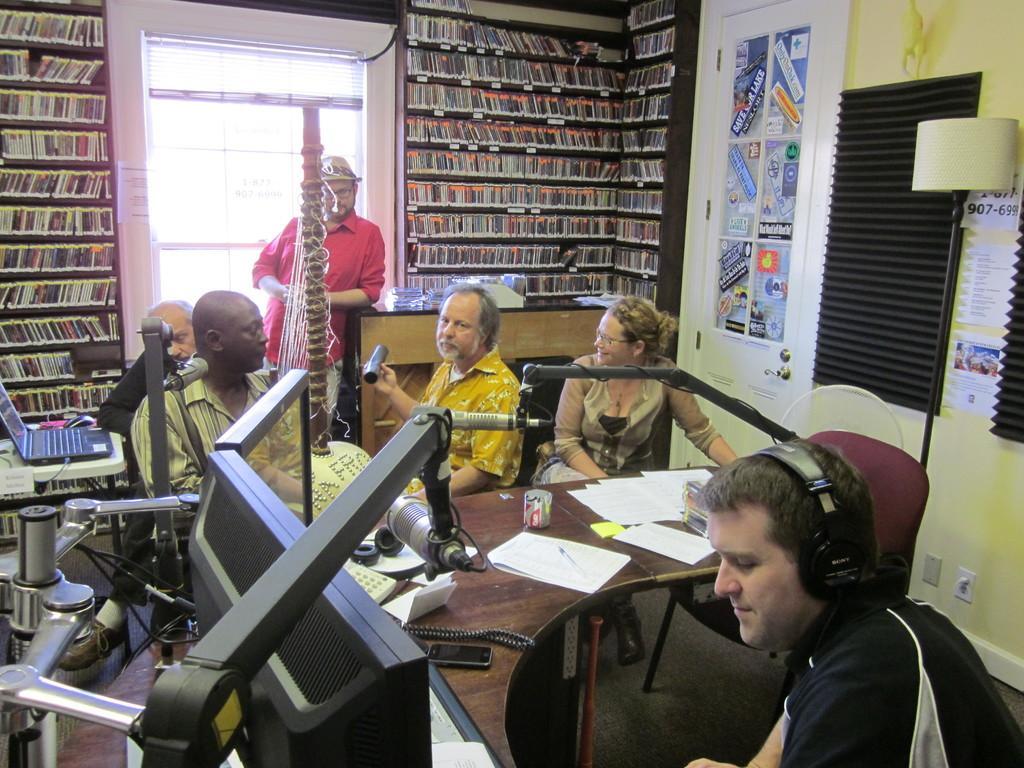How would you summarize this image in a sentence or two? In this image, we can see persons wearing clothes. There is a table at the bottom of the image contains papers, phone and monitor. There is a microphone arm in the bottom left of the image. There is an another table in front of the window. There is a door in the middle of the image. There are racks contains some objects. There is a lamp and window blind on the right side of the image. There is a laptop on the left side of the image. 